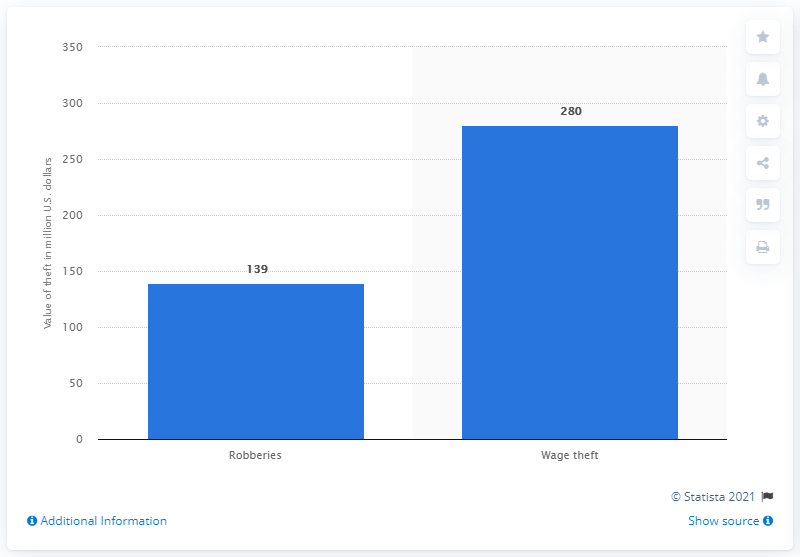Mention a couple of crucial points in this snapshot. In 2012, there were a total of 139 reported incidents of street, bank, gas station, and convenience store robberies. In 2012, approximately 280 million dollars were stolen by employers from their employees. 